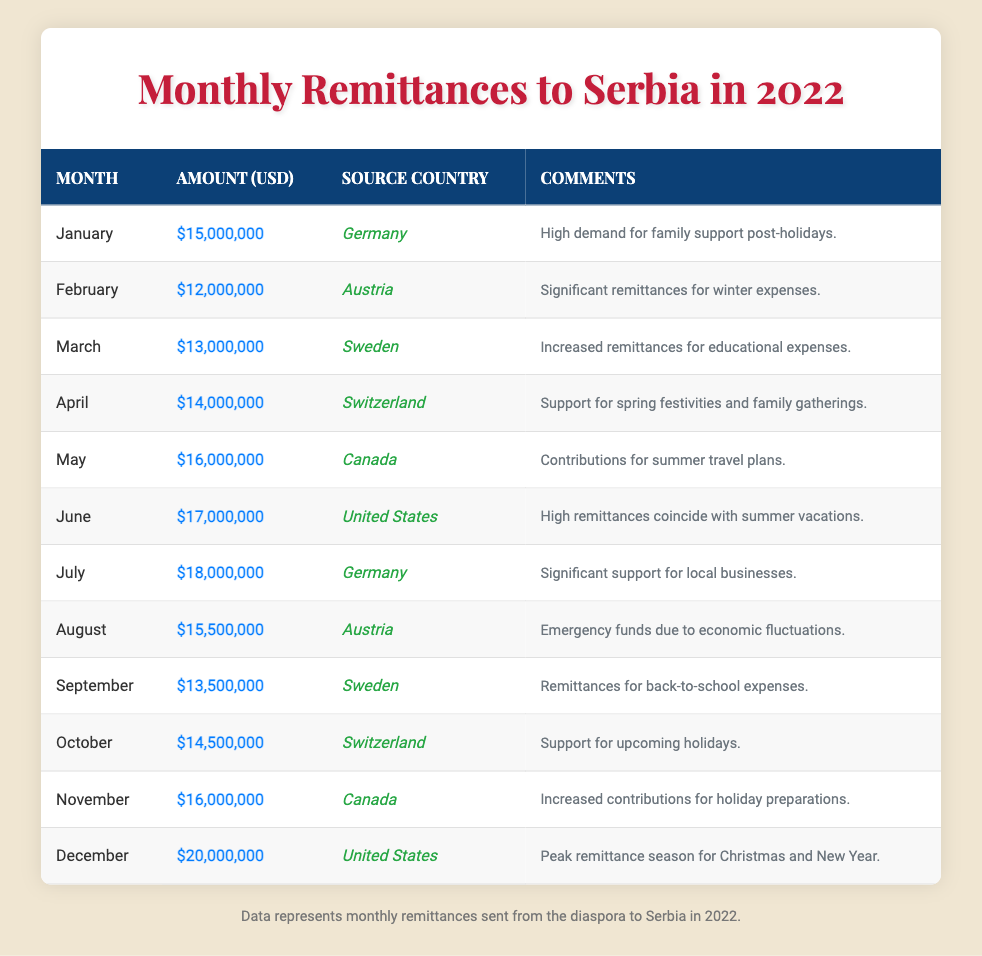What was the highest amount of remittances sent in a month? According to the table, the highest amount of remittances occurred in December, which was $20,000,000.
Answer: $20,000,000 Which country sent the most remittances in July? The table shows that Germany sent the most remittances in July, amounting to $18,000,000.
Answer: Germany What were the total remittances sent in the first half of the year (January to June)? To calculate this, sum the monthly amounts for January ($15,000,000), February ($12,000,000), March ($13,000,000), April ($14,000,000), May ($16,000,000), and June ($17,000,000). This gives: 15 + 12 + 13 + 14 + 16 + 17 = 87,000,000.
Answer: $87,000,000 In which month was there a peak in remittances for holiday preparations? The table indicates that November saw an increase in contributions for holiday preparations, with remittances totaling $16,000,000.
Answer: November How much less was sent in February compared to January? The amount sent in January was $15,000,000, and in February it was $12,000,000. The difference is $15,000,000 - $12,000,000 = $3,000,000.
Answer: $3,000,000 What is the average remittance amount throughout the year? To find the average, sum all monthly remittances: $15M + $12M + $13M + $14M + $16M + $17M + $18M + $15.5M + $13.5M + $14.5M + $16M + $20M = $187M. There are 12 months, so the average is $187M / 12 = $15.58M.
Answer: $15,583,333 Did the remittances sent from Austria increase or decrease from February to August? In February the remittances from Austria were $12,000,000 and in August it was $15,500,000. Since $15,500,000 is greater than $12,000,000, it indicates an increase.
Answer: Yes, it increased What was the total amount sent from Canada in May and November? In May, the remittance amount from Canada was $16,000,000 and in November it was also $16,000,000. Therefore, the total is $16,000,000 + $16,000,000 = $32,000,000.
Answer: $32,000,000 Which month had lower remittances, September or October? The table indicates September had $13,500,000 and October had $14,500,000. Therefore, September had lower remittances.
Answer: September Was the comment regarding economic fluctuations linked to a higher or lower remittance month? The comment related to economic fluctuations appears in August, which had $15,500,000 in remittances. Comparing this to other months, it is lower than the months around it such as July ($18,000,000) and June ($17,000,000). Thus, it is linked to a lower remittance month.
Answer: Lower 